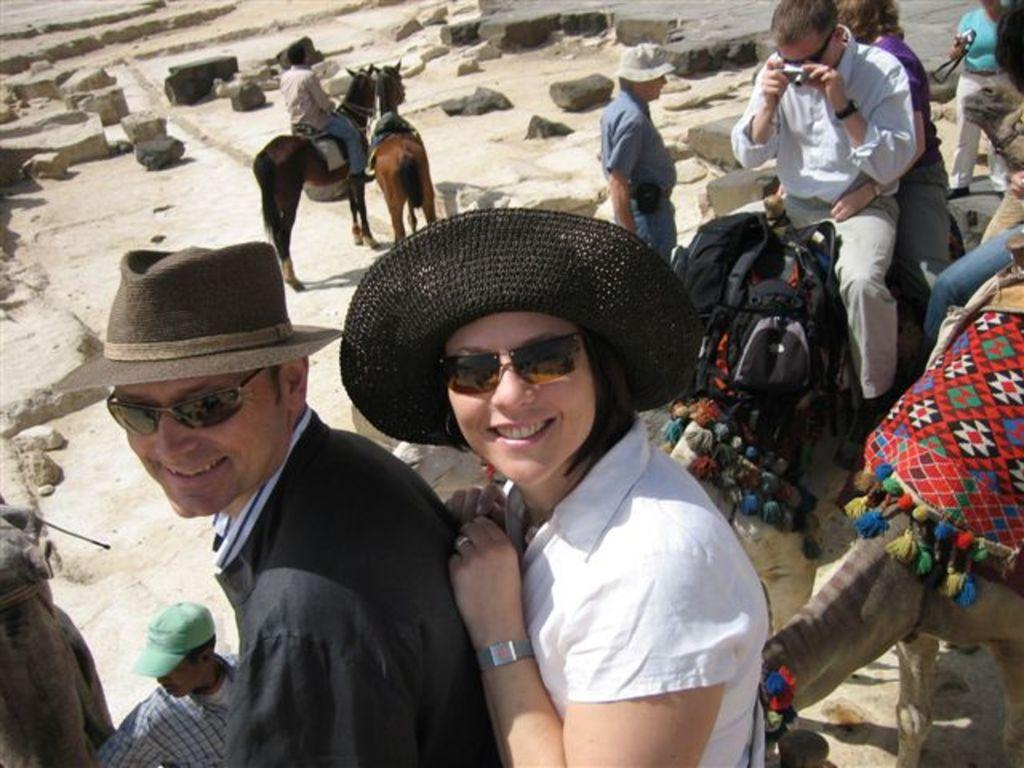How many people are in the image? There are many persons in the image. What animals are present in the image? There are camels in the image. What are some people doing with the camels? Some persons are sitting on the camels. What other animals can be seen at the top of the image? There are horses visible at the top of the image. What type of guitar can be seen being played by the camels in the image? There are no guitars present in the image, and camels cannot play musical instruments. 